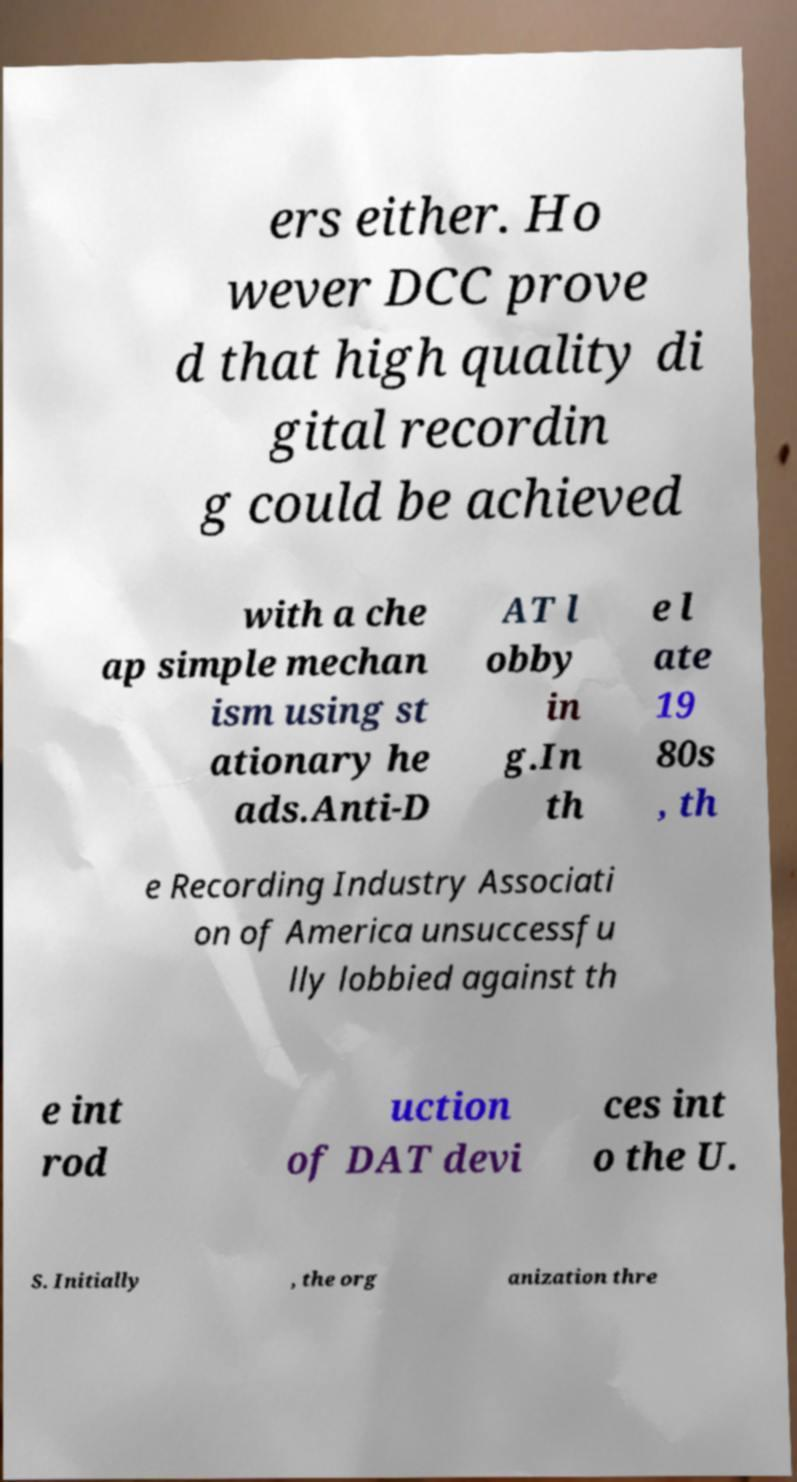Please identify and transcribe the text found in this image. ers either. Ho wever DCC prove d that high quality di gital recordin g could be achieved with a che ap simple mechan ism using st ationary he ads.Anti-D AT l obby in g.In th e l ate 19 80s , th e Recording Industry Associati on of America unsuccessfu lly lobbied against th e int rod uction of DAT devi ces int o the U. S. Initially , the org anization thre 